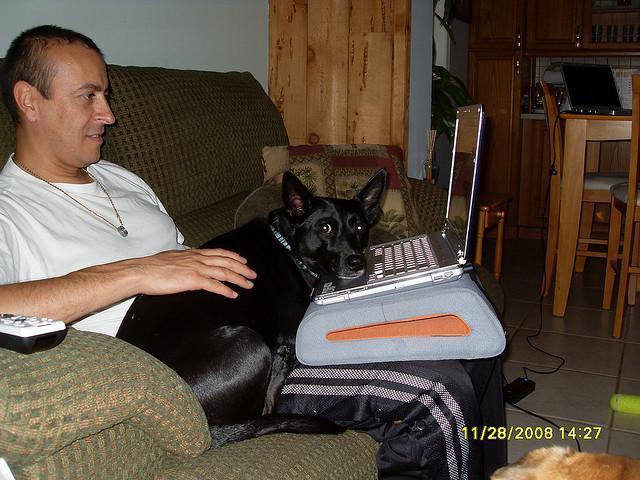How many laptops are there?
Give a very brief answer. 2. How many chairs are there?
Give a very brief answer. 2. How many remotes are visible?
Give a very brief answer. 1. How many couches are in the photo?
Give a very brief answer. 2. How many motorcycles are there?
Give a very brief answer. 0. 